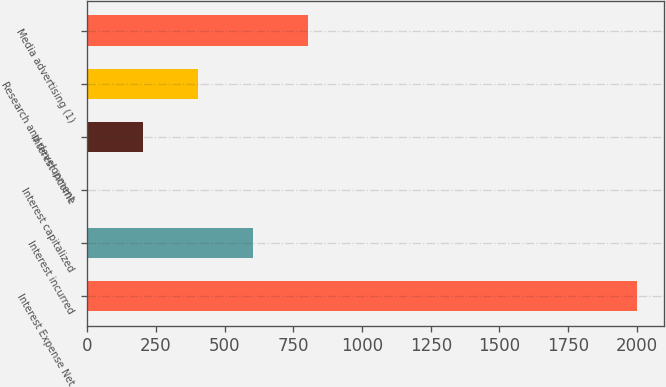Convert chart to OTSL. <chart><loc_0><loc_0><loc_500><loc_500><bar_chart><fcel>Interest Expense Net<fcel>Interest incurred<fcel>Interest capitalized<fcel>Interest income<fcel>Research and development<fcel>Media advertising (1)<nl><fcel>2000<fcel>602.66<fcel>3.8<fcel>203.42<fcel>403.04<fcel>802.28<nl></chart> 